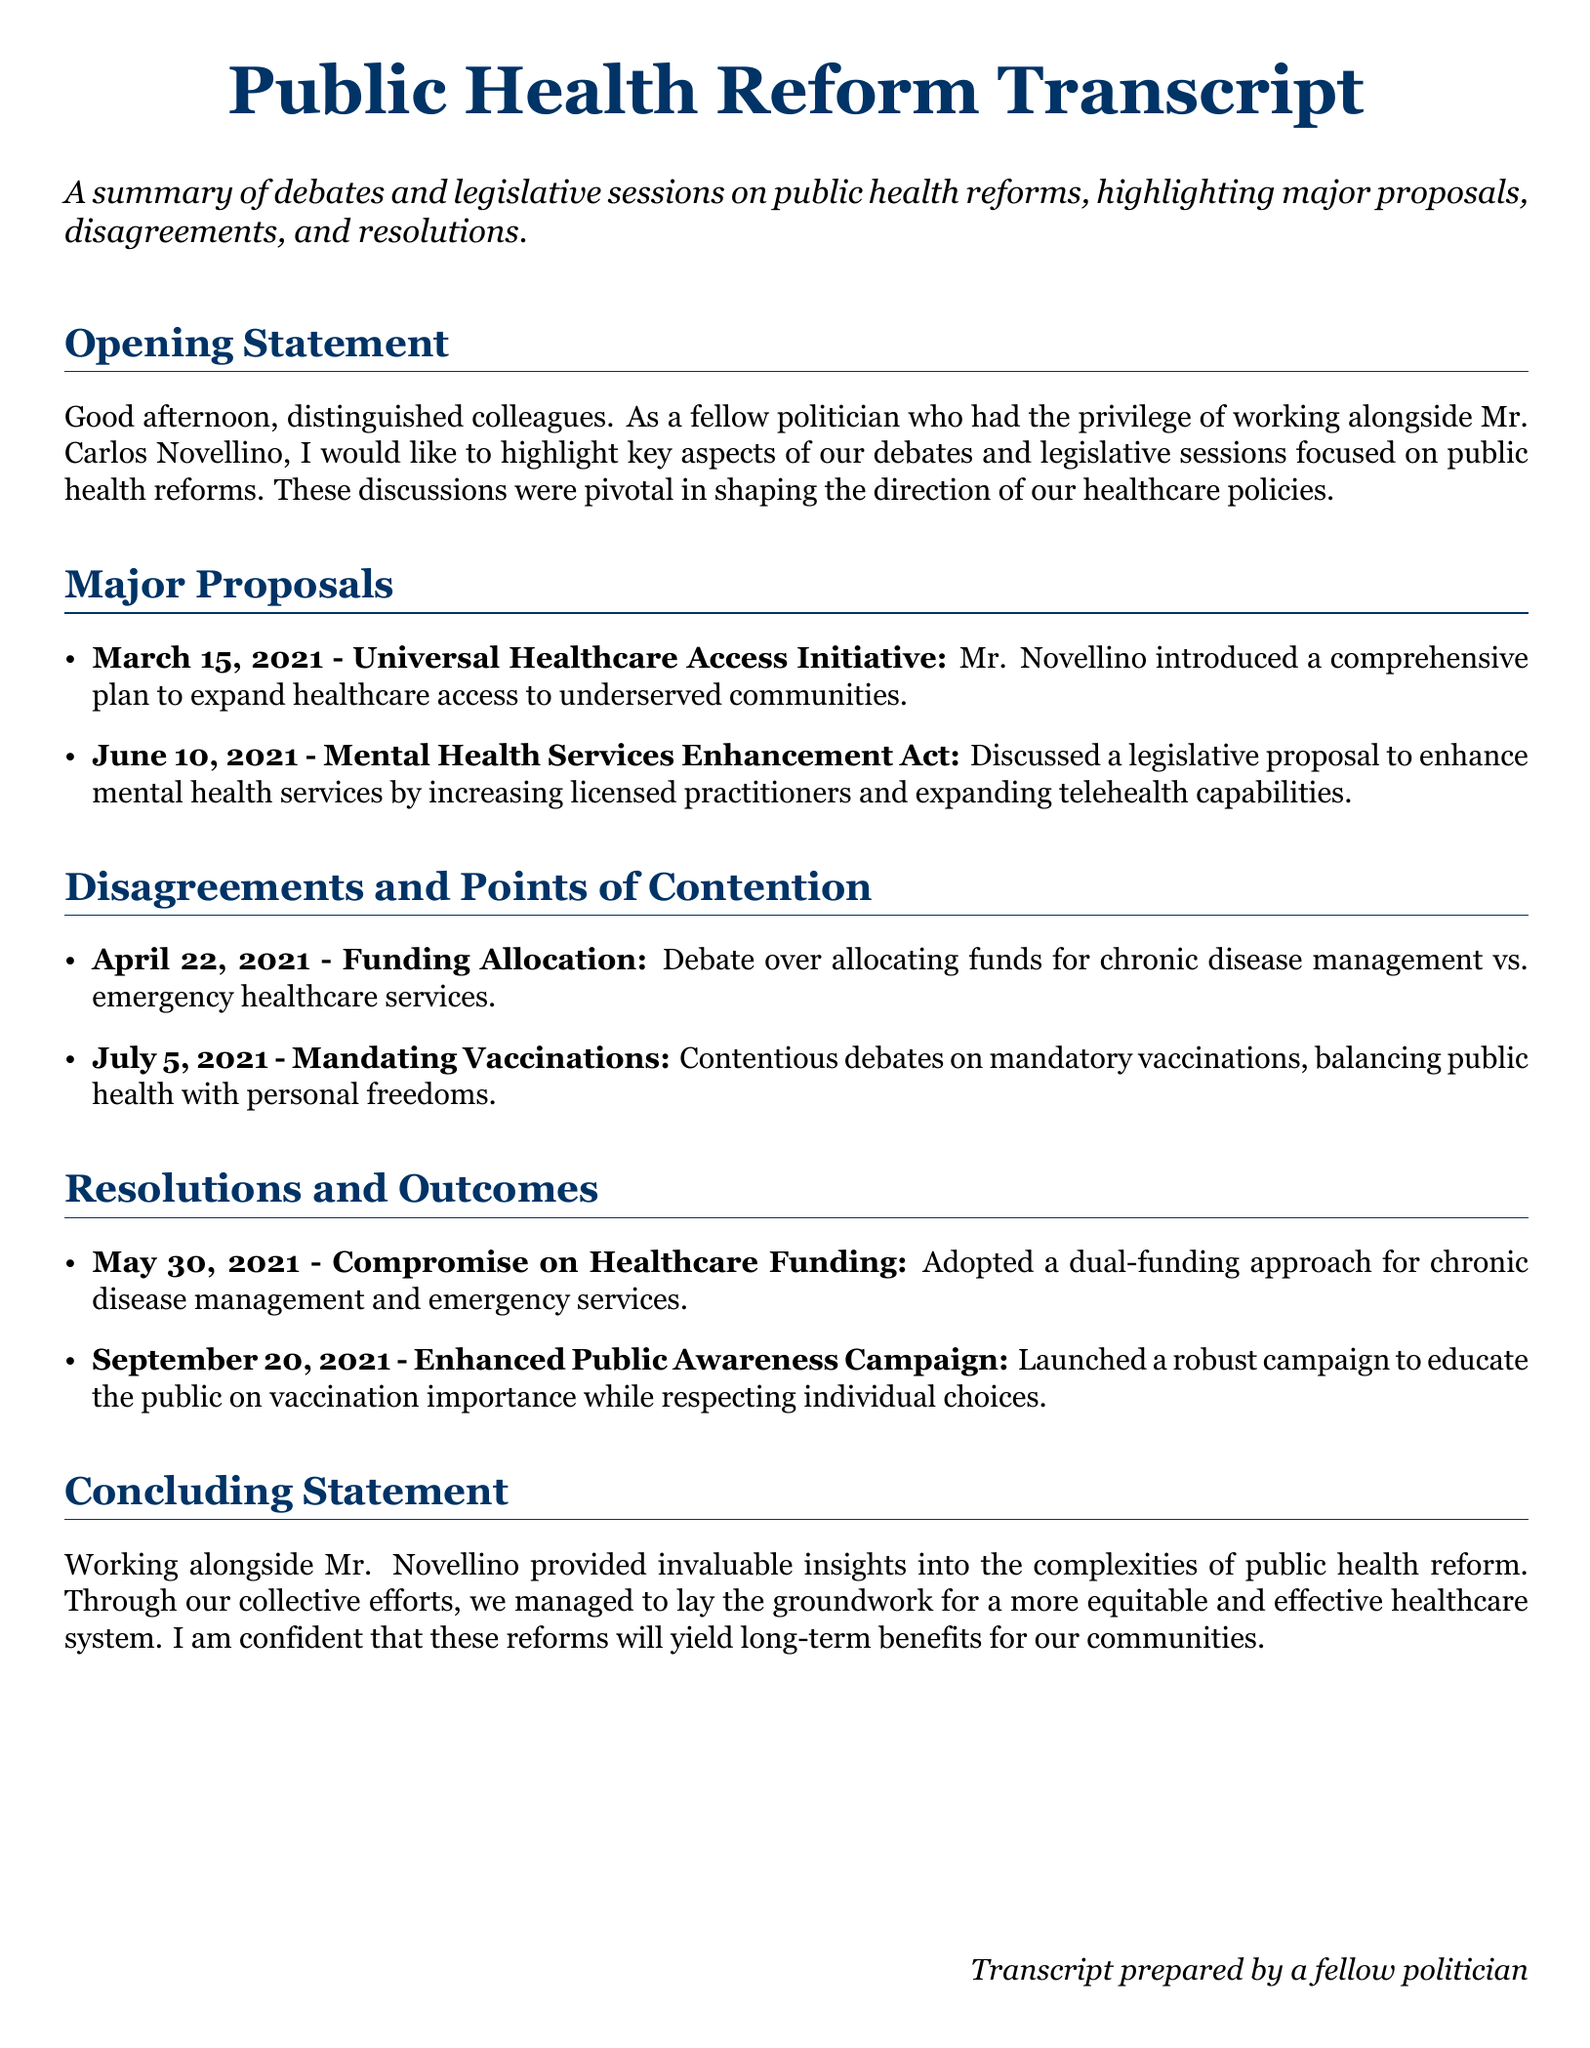What was introduced on March 15, 2021? The document states that on March 15, 2021, a comprehensive plan was introduced to expand healthcare access to underserved communities.
Answer: Universal Healthcare Access Initiative What act was discussed on June 10, 2021? The document mentions a legislative proposal discussed on June 10, 2021, aimed at enhancing mental health services.
Answer: Mental Health Services Enhancement Act What topic was debated on April 22, 2021? The document notes a debate regarding the allocation of funds for chronic disease management vs. emergency healthcare services on April 22, 2021.
Answer: Funding Allocation What was the resolution regarding healthcare funding on May 30, 2021? According to the document, the resolution adopted a dual-funding approach for chronic disease management and emergency services on May 30, 2021.
Answer: Compromise on Healthcare Funding What was the focus of the campaign launched on September 20, 2021? The document indicates that the campaign launched on September 20, 2021, focused on educating the public on vaccination importance.
Answer: Enhanced Public Awareness Campaign What underlying issue was addressed in the discussion about vaccinations? The document highlights that the discussions around vaccinations involved balancing public health with personal freedoms.
Answer: Personal freedoms 